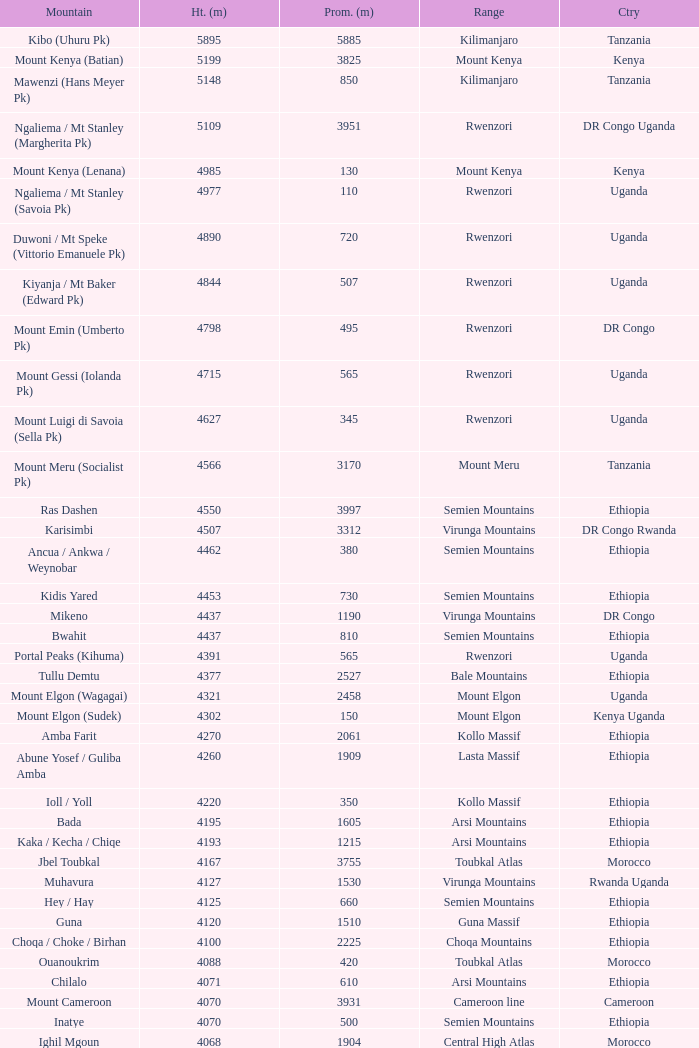How tall is the Mountain of jbel ghat? 1.0. 